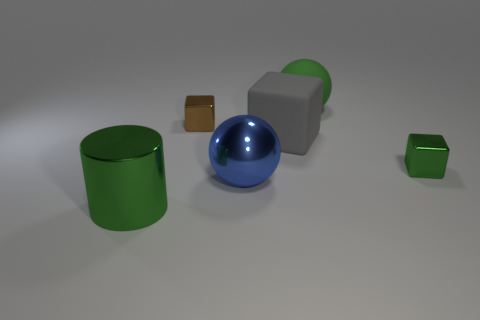Is the metallic ball the same color as the large cube? no 